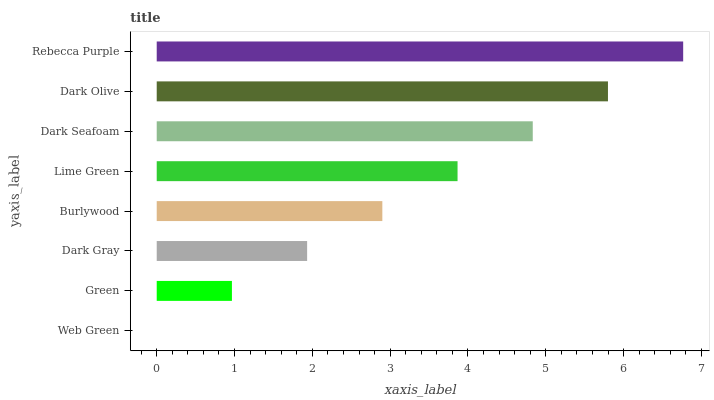Is Web Green the minimum?
Answer yes or no. Yes. Is Rebecca Purple the maximum?
Answer yes or no. Yes. Is Green the minimum?
Answer yes or no. No. Is Green the maximum?
Answer yes or no. No. Is Green greater than Web Green?
Answer yes or no. Yes. Is Web Green less than Green?
Answer yes or no. Yes. Is Web Green greater than Green?
Answer yes or no. No. Is Green less than Web Green?
Answer yes or no. No. Is Lime Green the high median?
Answer yes or no. Yes. Is Burlywood the low median?
Answer yes or no. Yes. Is Green the high median?
Answer yes or no. No. Is Dark Gray the low median?
Answer yes or no. No. 